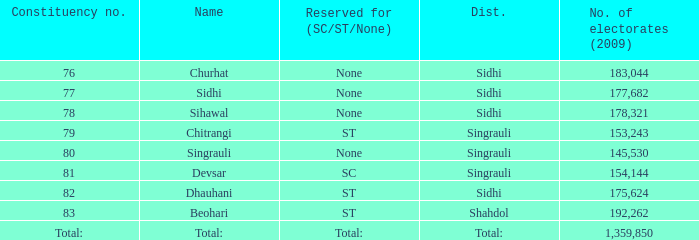What is Beohari's highest number of electorates? 192262.0. Could you parse the entire table as a dict? {'header': ['Constituency no.', 'Name', 'Reserved for (SC/ST/None)', 'Dist.', 'No. of electorates (2009)'], 'rows': [['76', 'Churhat', 'None', 'Sidhi', '183,044'], ['77', 'Sidhi', 'None', 'Sidhi', '177,682'], ['78', 'Sihawal', 'None', 'Sidhi', '178,321'], ['79', 'Chitrangi', 'ST', 'Singrauli', '153,243'], ['80', 'Singrauli', 'None', 'Singrauli', '145,530'], ['81', 'Devsar', 'SC', 'Singrauli', '154,144'], ['82', 'Dhauhani', 'ST', 'Sidhi', '175,624'], ['83', 'Beohari', 'ST', 'Shahdol', '192,262'], ['Total:', 'Total:', 'Total:', 'Total:', '1,359,850']]} 